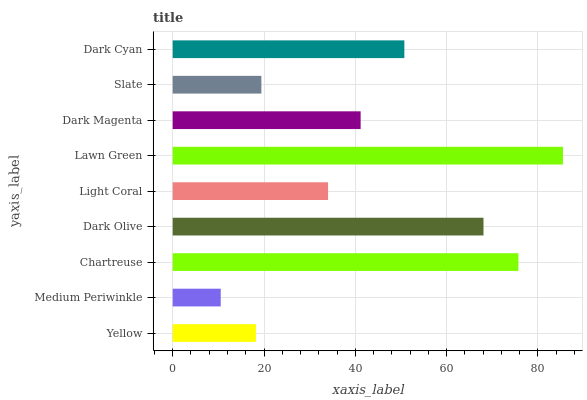Is Medium Periwinkle the minimum?
Answer yes or no. Yes. Is Lawn Green the maximum?
Answer yes or no. Yes. Is Chartreuse the minimum?
Answer yes or no. No. Is Chartreuse the maximum?
Answer yes or no. No. Is Chartreuse greater than Medium Periwinkle?
Answer yes or no. Yes. Is Medium Periwinkle less than Chartreuse?
Answer yes or no. Yes. Is Medium Periwinkle greater than Chartreuse?
Answer yes or no. No. Is Chartreuse less than Medium Periwinkle?
Answer yes or no. No. Is Dark Magenta the high median?
Answer yes or no. Yes. Is Dark Magenta the low median?
Answer yes or no. Yes. Is Slate the high median?
Answer yes or no. No. Is Lawn Green the low median?
Answer yes or no. No. 